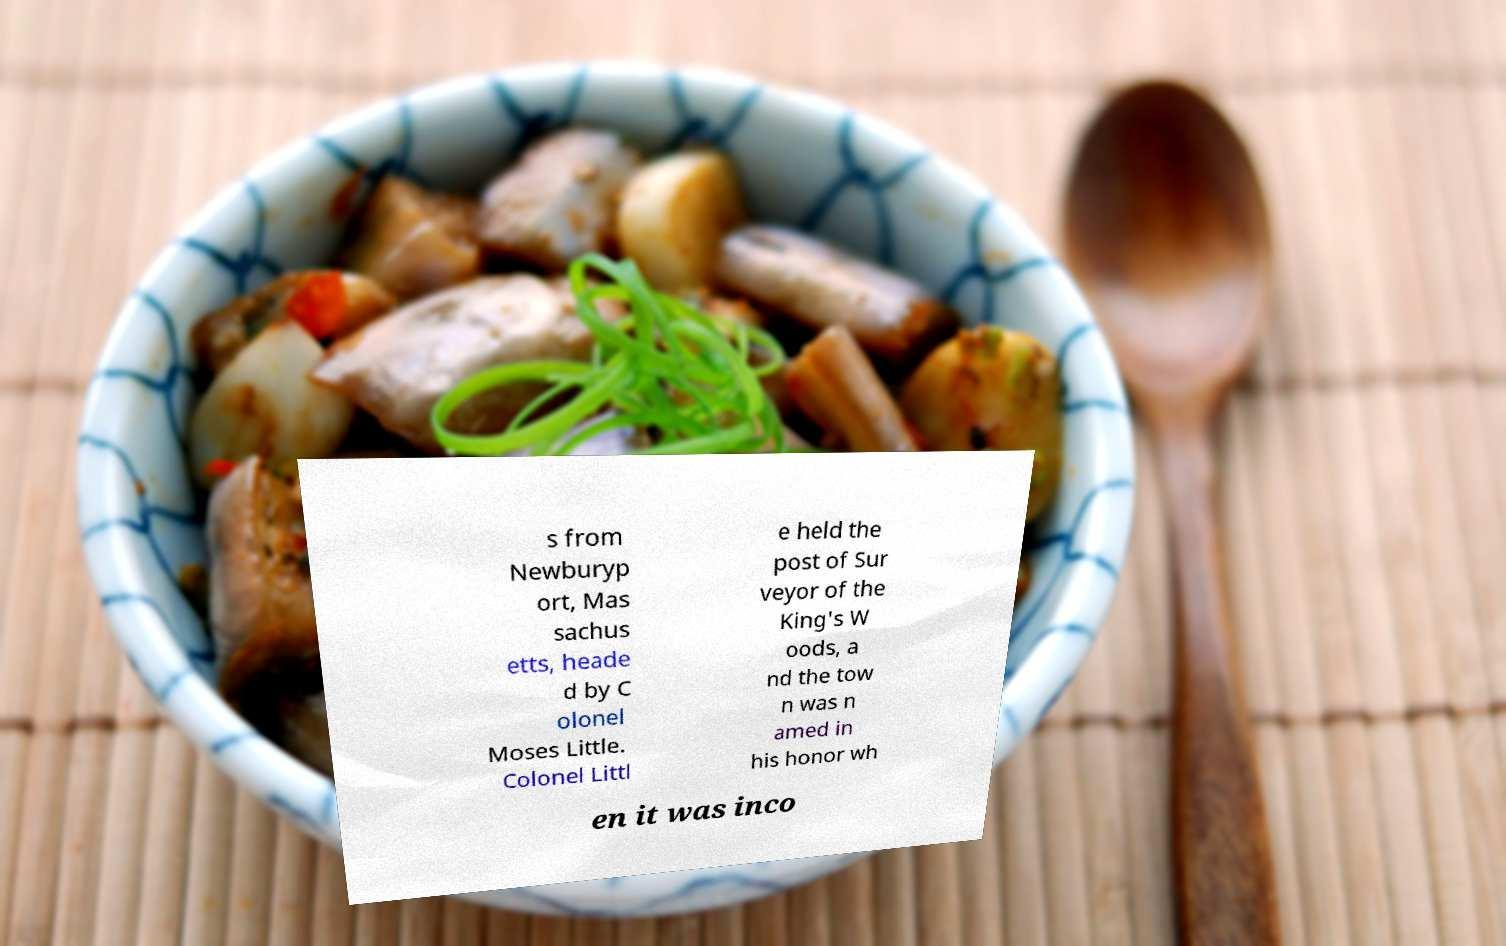What messages or text are displayed in this image? I need them in a readable, typed format. s from Newburyp ort, Mas sachus etts, heade d by C olonel Moses Little. Colonel Littl e held the post of Sur veyor of the King's W oods, a nd the tow n was n amed in his honor wh en it was inco 